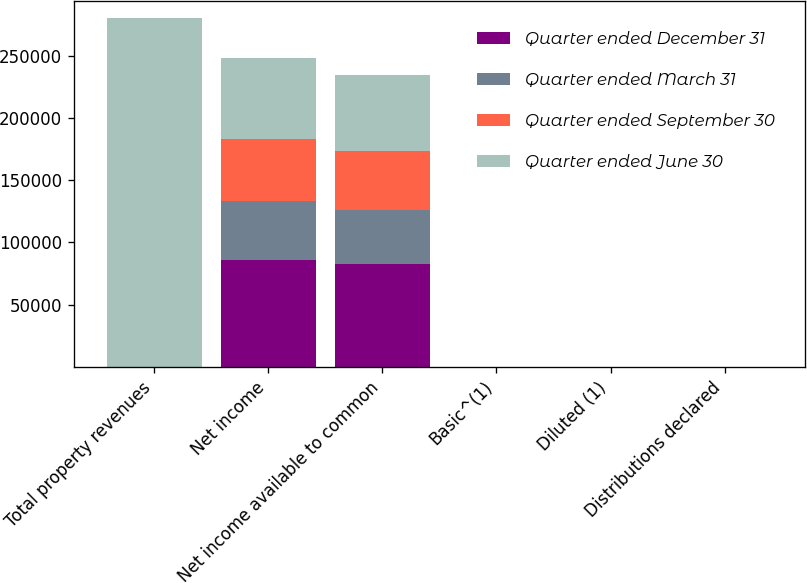<chart> <loc_0><loc_0><loc_500><loc_500><stacked_bar_chart><ecel><fcel>Total property revenues<fcel>Net income<fcel>Net income available to common<fcel>Basic^(1)<fcel>Diluted (1)<fcel>Distributions declared<nl><fcel>Quarter ended December 31<fcel>1.44<fcel>85762<fcel>82333<fcel>1.22<fcel>1.22<fcel>1.44<nl><fcel>Quarter ended March 31<fcel>1.44<fcel>47182<fcel>43794<fcel>0.65<fcel>0.65<fcel>1.44<nl><fcel>Quarter ended September 30<fcel>1.44<fcel>50542<fcel>47088<fcel>0.7<fcel>0.7<fcel>1.44<nl><fcel>Quarter ended June 30<fcel>280229<fcel>64753<fcel>61474<fcel>0.93<fcel>0.92<fcel>1.44<nl></chart> 